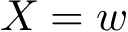<formula> <loc_0><loc_0><loc_500><loc_500>X = w</formula> 